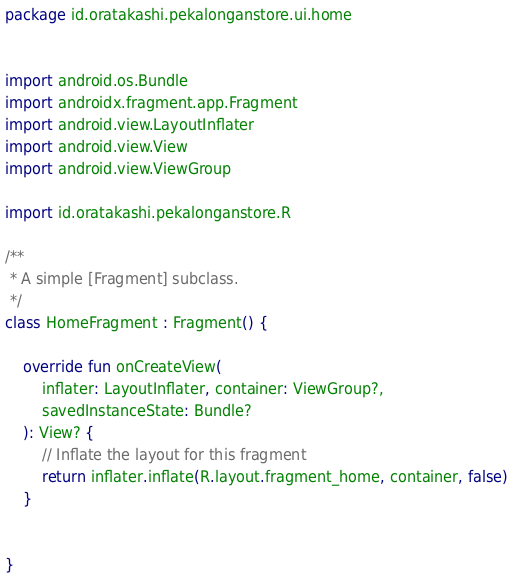<code> <loc_0><loc_0><loc_500><loc_500><_Kotlin_>package id.oratakashi.pekalonganstore.ui.home


import android.os.Bundle
import androidx.fragment.app.Fragment
import android.view.LayoutInflater
import android.view.View
import android.view.ViewGroup

import id.oratakashi.pekalonganstore.R

/**
 * A simple [Fragment] subclass.
 */
class HomeFragment : Fragment() {

    override fun onCreateView(
        inflater: LayoutInflater, container: ViewGroup?,
        savedInstanceState: Bundle?
    ): View? {
        // Inflate the layout for this fragment
        return inflater.inflate(R.layout.fragment_home, container, false)
    }


}
</code> 